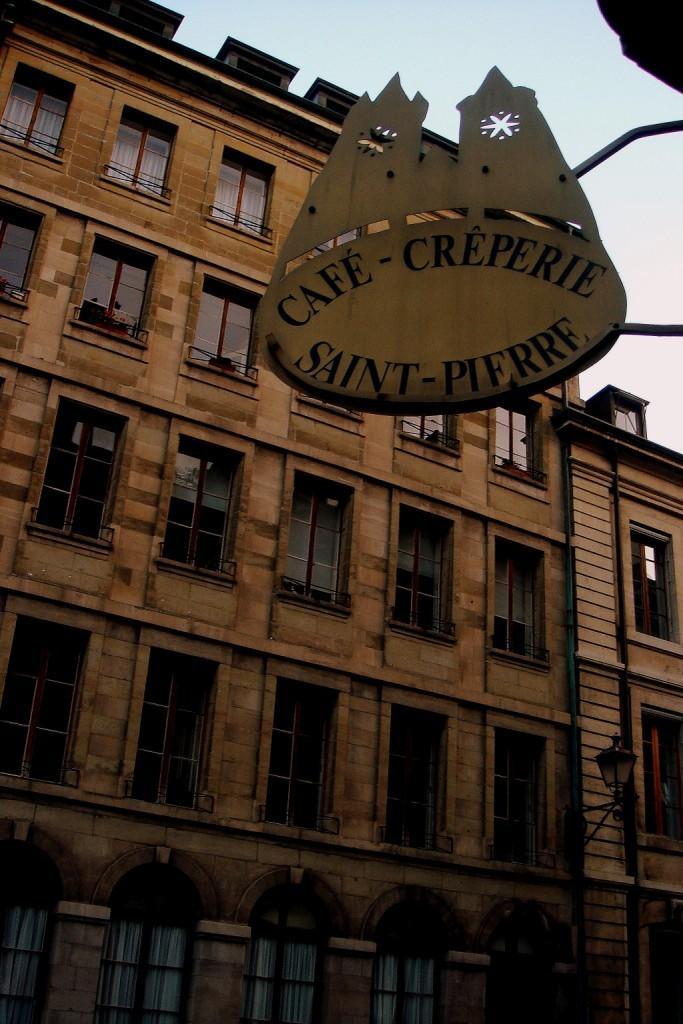Please provide a concise description of this image. In this picture we can see a building,windows and we can see sky in the background. 